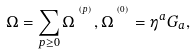Convert formula to latex. <formula><loc_0><loc_0><loc_500><loc_500>\Omega = \sum _ { p \geq 0 } { \Omega } \, ^ { ^ { ^ { ( p ) } } } , { \Omega } \, ^ { ^ { ^ { ( 0 ) } } } = \eta ^ { a } G _ { a } ,</formula> 